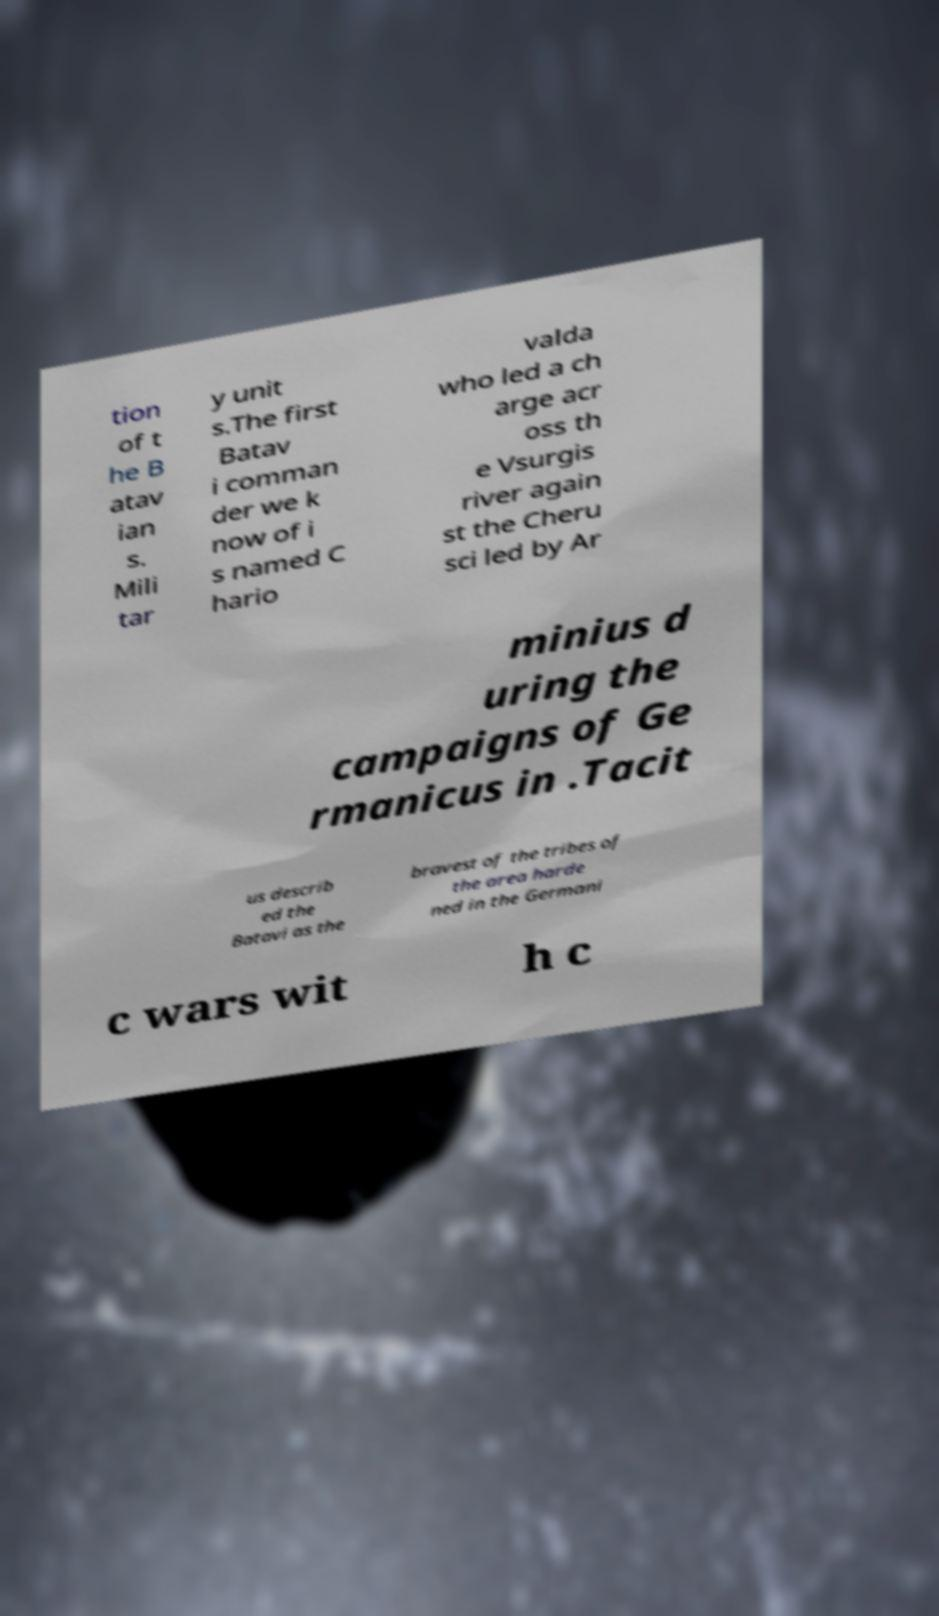Could you assist in decoding the text presented in this image and type it out clearly? tion of t he B atav ian s. Mili tar y unit s.The first Batav i comman der we k now of i s named C hario valda who led a ch arge acr oss th e Vsurgis river again st the Cheru sci led by Ar minius d uring the campaigns of Ge rmanicus in .Tacit us describ ed the Batavi as the bravest of the tribes of the area harde ned in the Germani c wars wit h c 